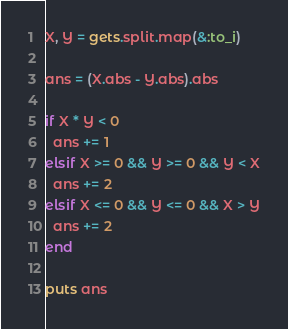<code> <loc_0><loc_0><loc_500><loc_500><_Ruby_>X, Y = gets.split.map(&:to_i)

ans = (X.abs - Y.abs).abs

if X * Y < 0
  ans += 1
elsif X >= 0 && Y >= 0 && Y < X
  ans += 2
elsif X <= 0 && Y <= 0 && X > Y
  ans += 2
end

puts ans
</code> 